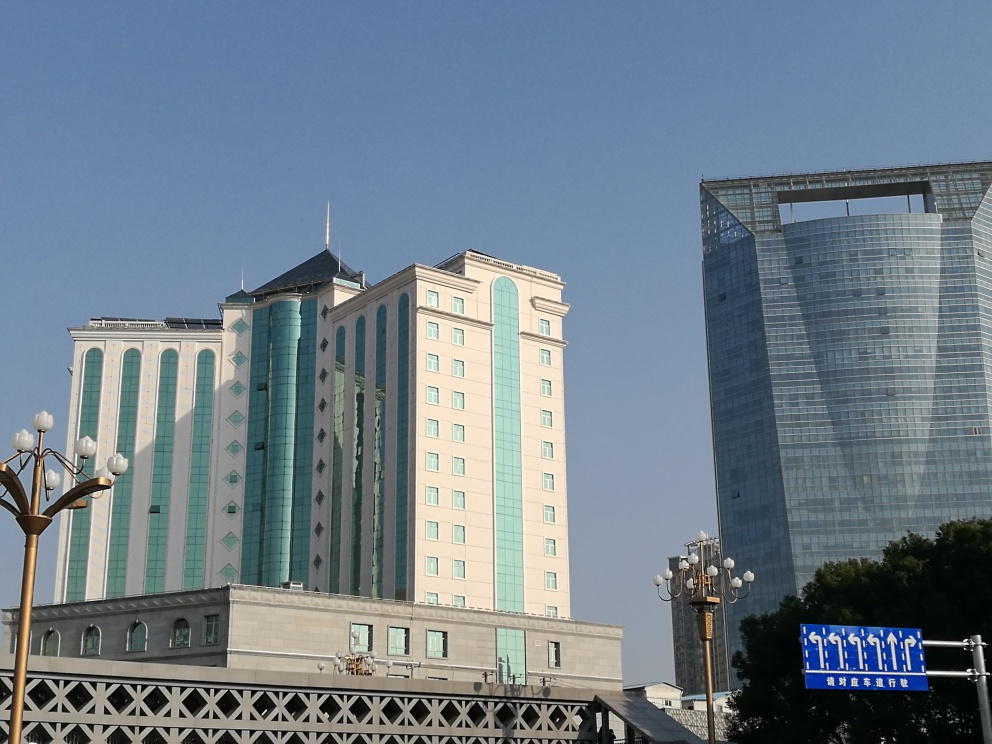What architectural styles are represented in this image? The image showcases a juxtaposition of architectural styles. On the left, we have a building with traditional influences, marked by its symmetrical features and classic roof design. On the right, there is a modern skyscraper with a glass facade and an unconventional, almost incomplete geometric shape at the top. 